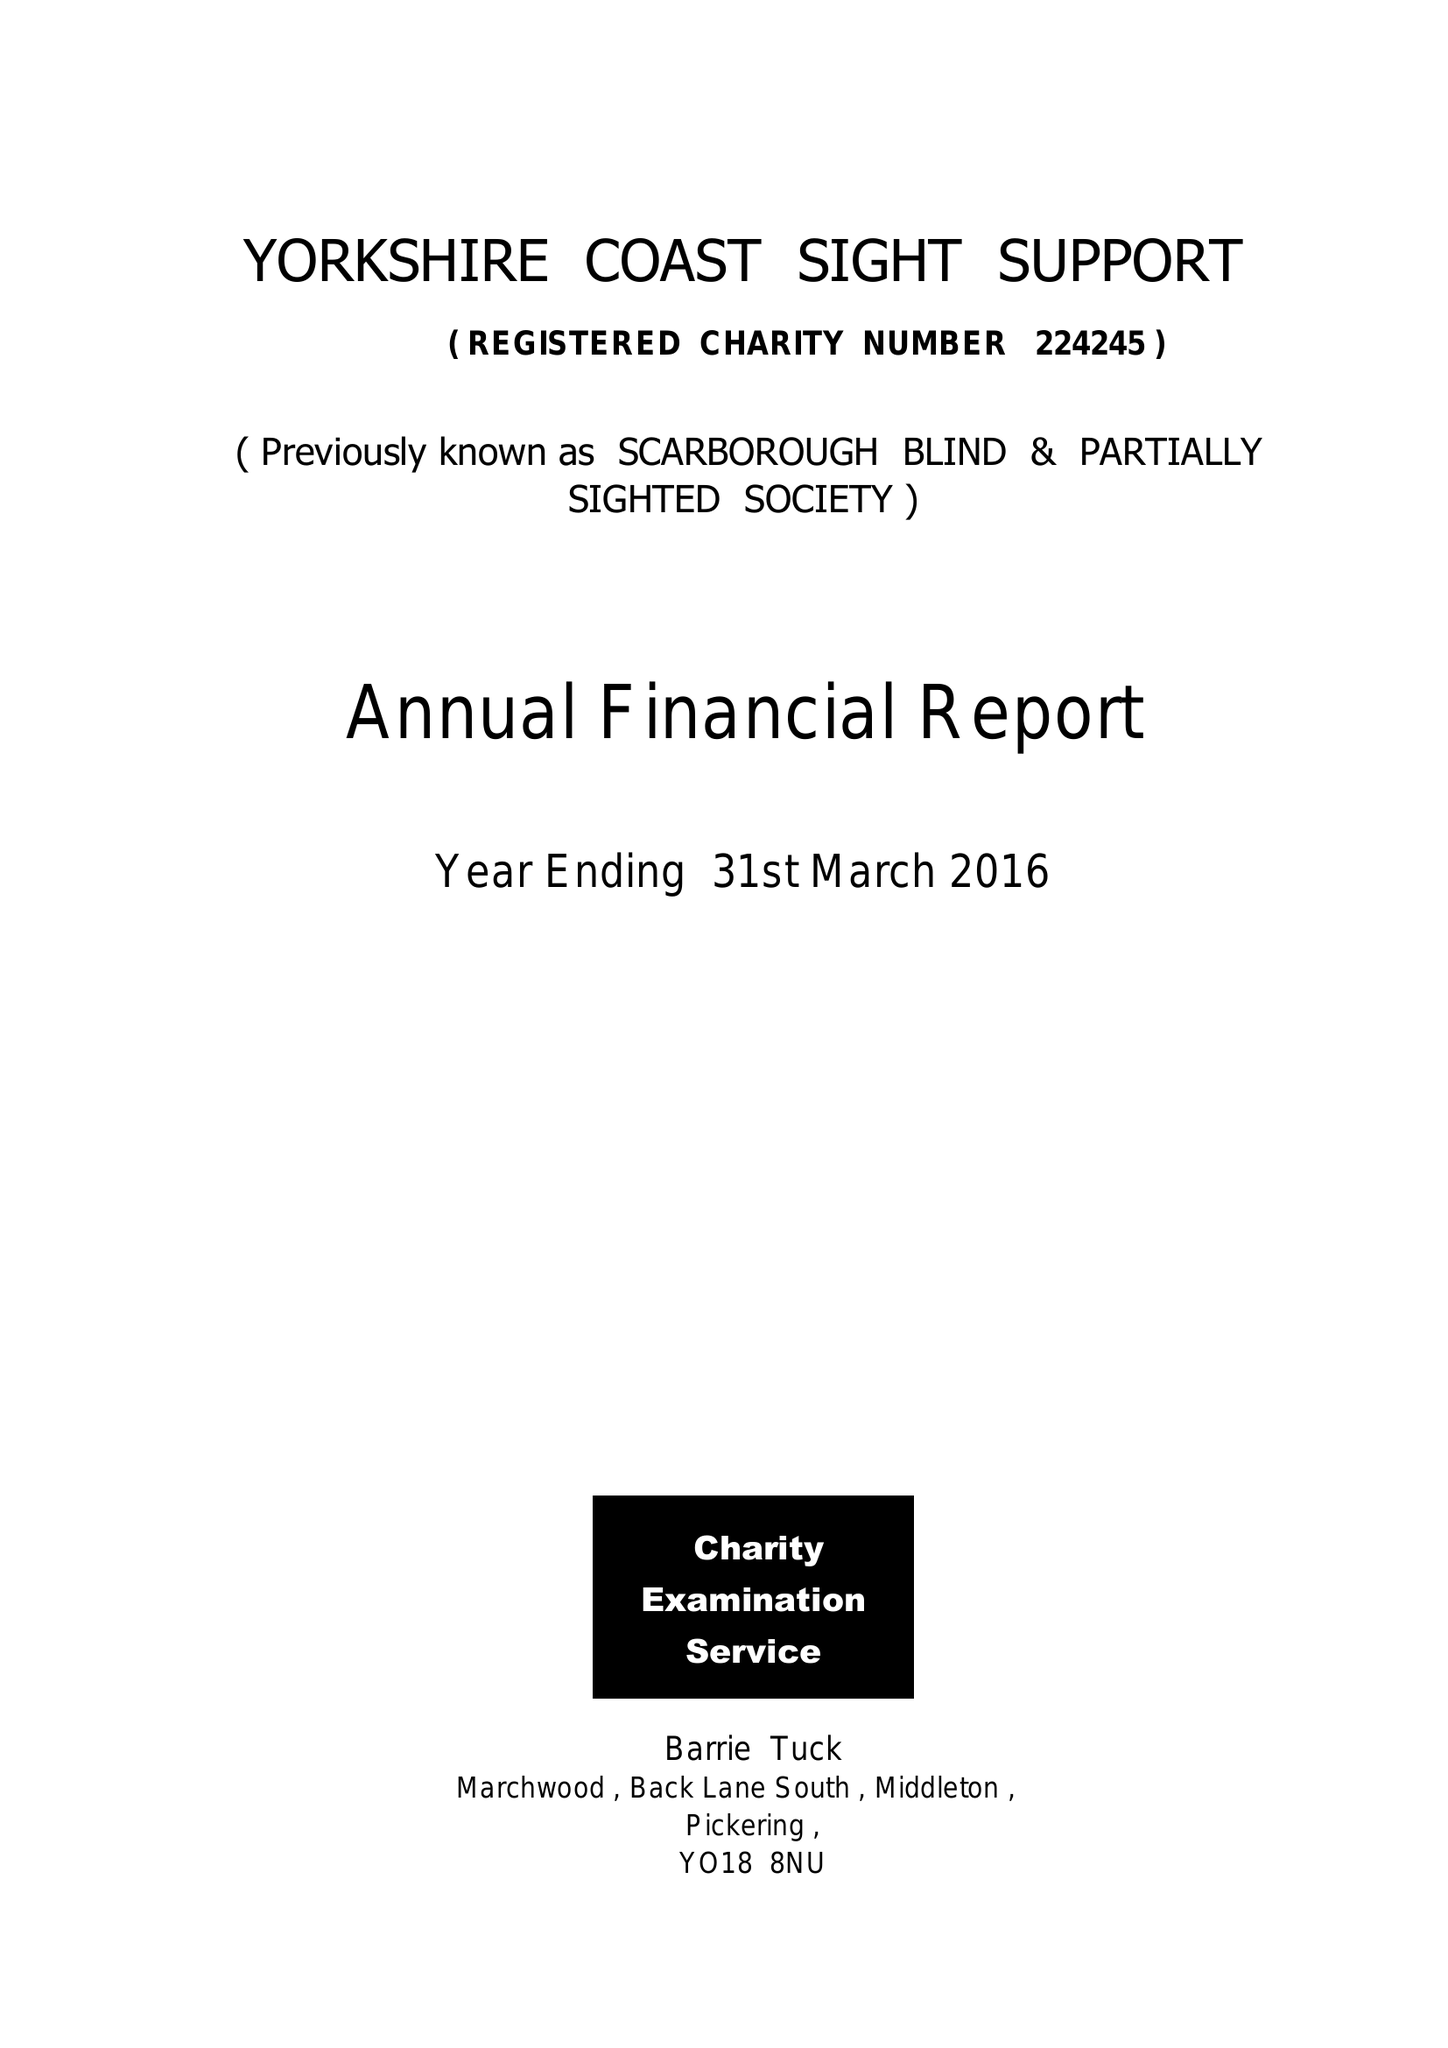What is the value for the address__street_line?
Answer the question using a single word or phrase. 181-183 DEAN ROAD 